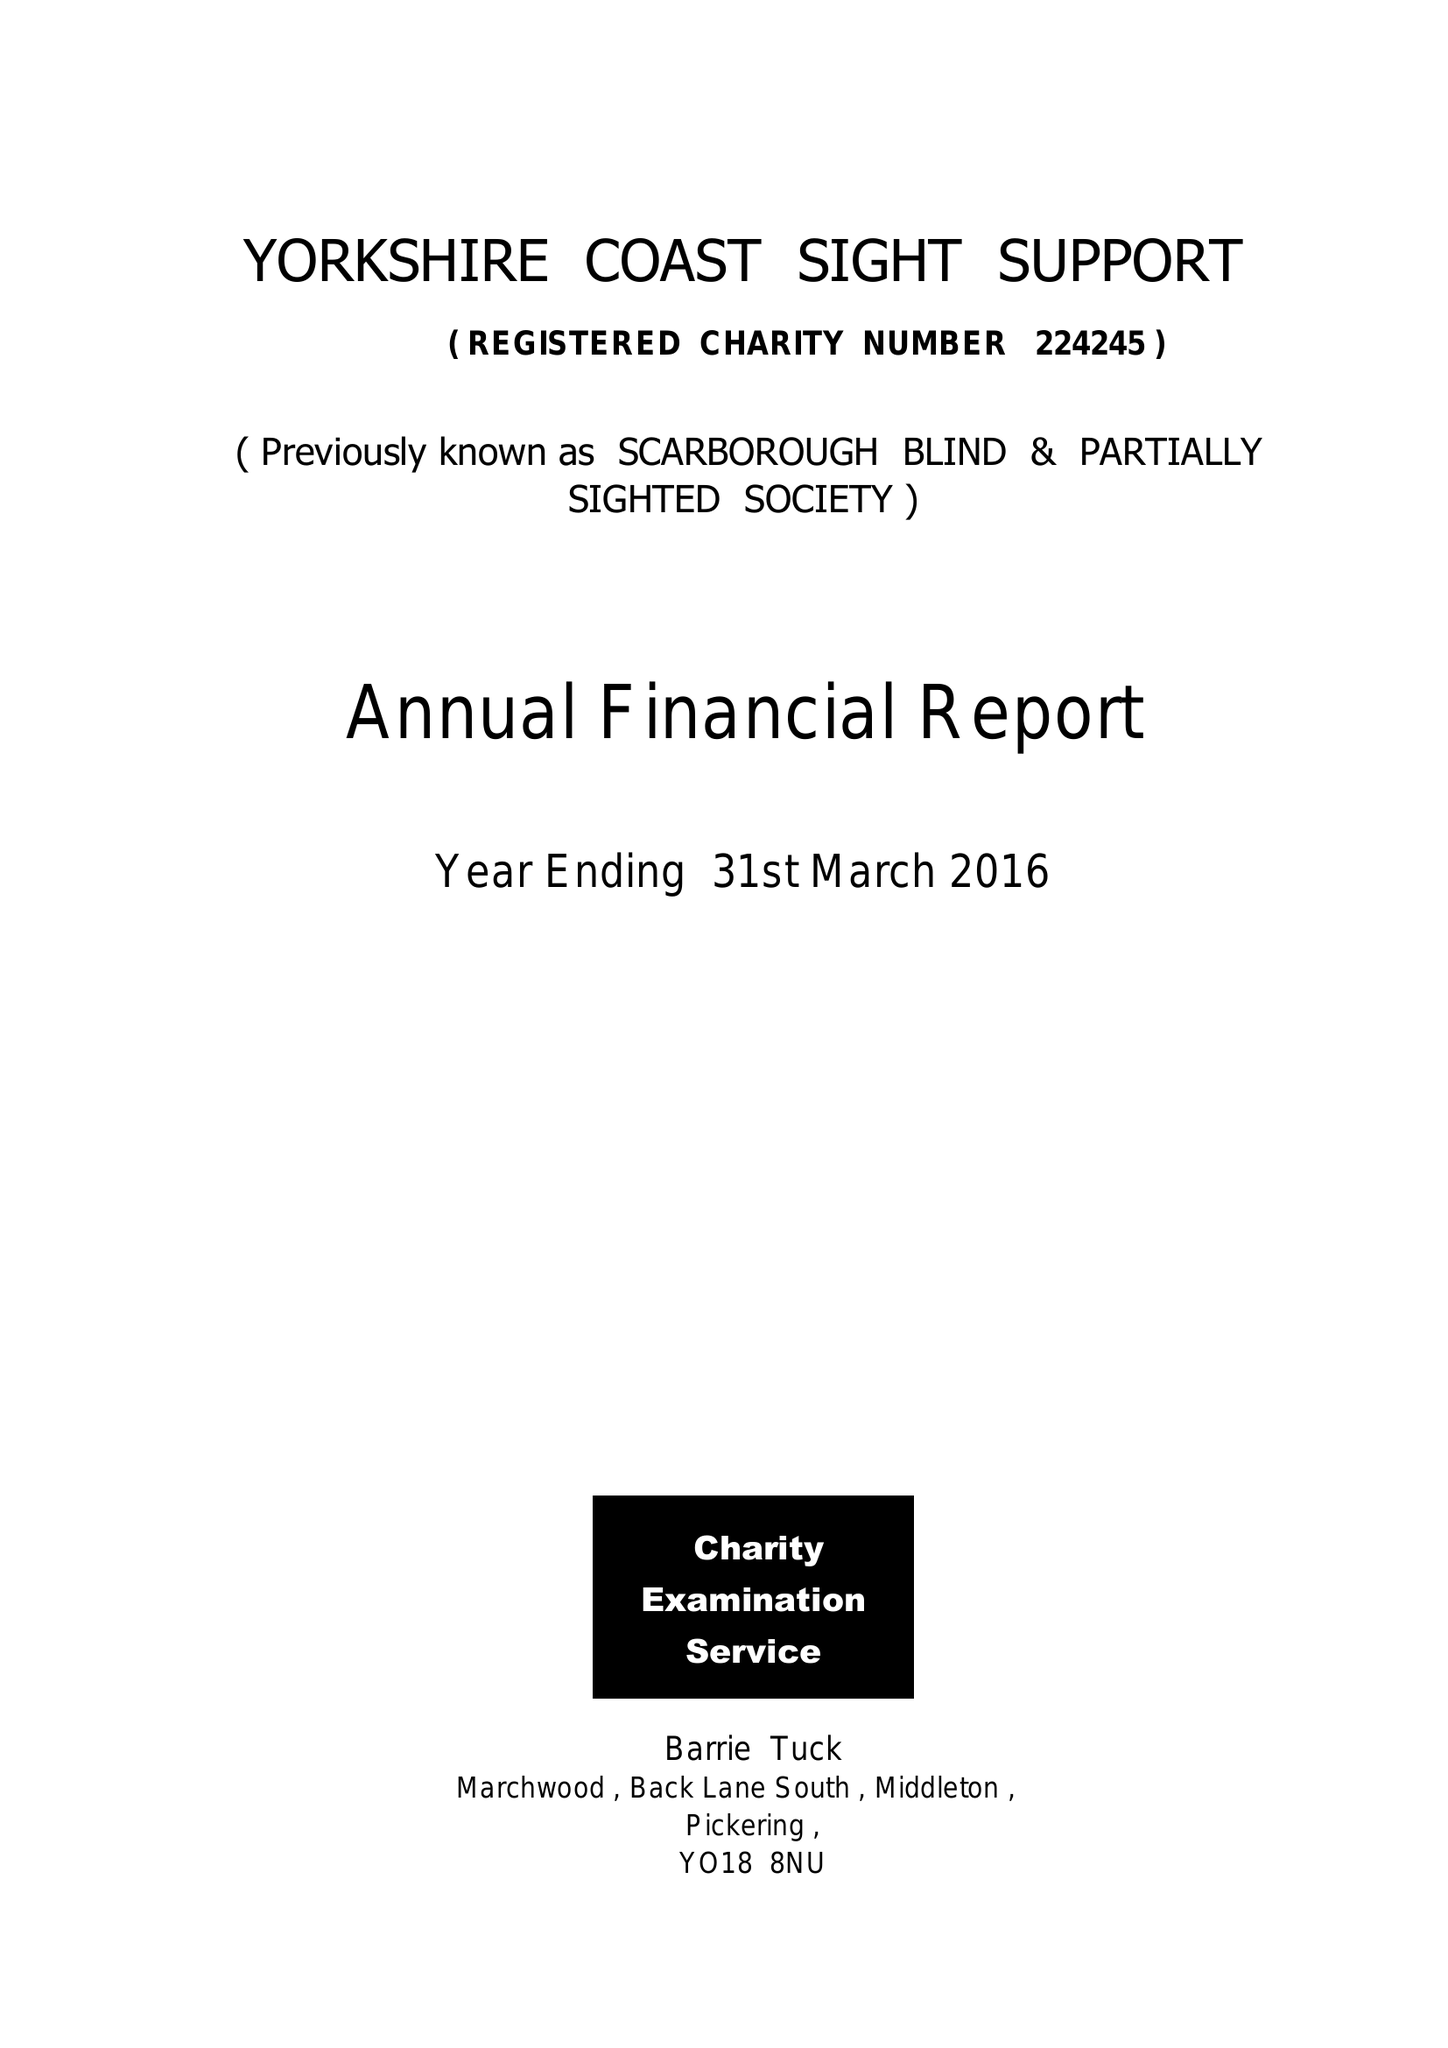What is the value for the address__street_line?
Answer the question using a single word or phrase. 181-183 DEAN ROAD 